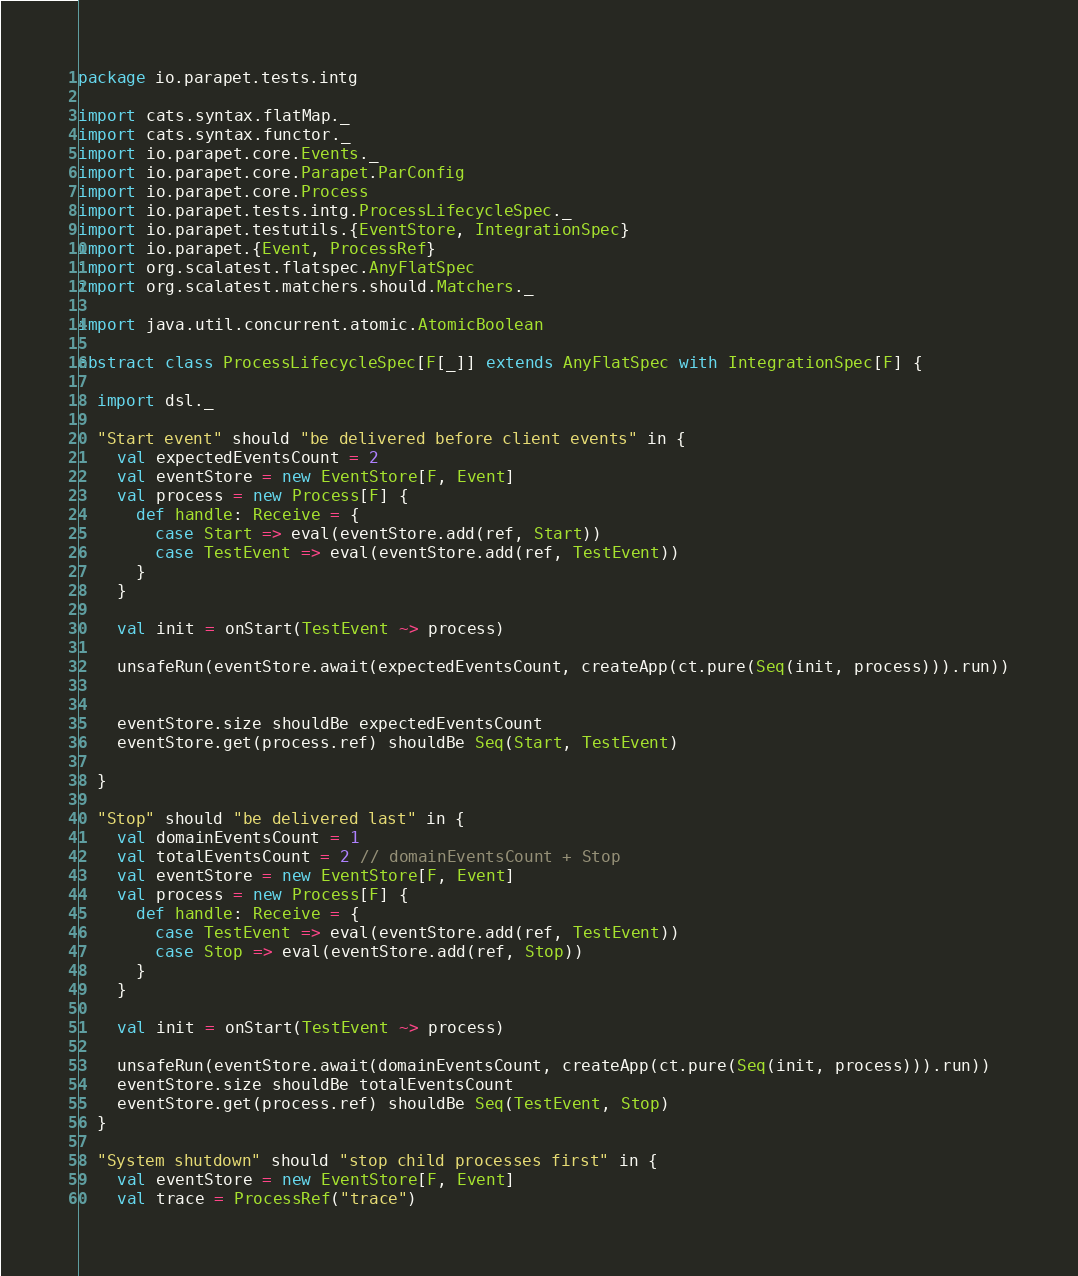<code> <loc_0><loc_0><loc_500><loc_500><_Scala_>package io.parapet.tests.intg

import cats.syntax.flatMap._
import cats.syntax.functor._
import io.parapet.core.Events._
import io.parapet.core.Parapet.ParConfig
import io.parapet.core.Process
import io.parapet.tests.intg.ProcessLifecycleSpec._
import io.parapet.testutils.{EventStore, IntegrationSpec}
import io.parapet.{Event, ProcessRef}
import org.scalatest.flatspec.AnyFlatSpec
import org.scalatest.matchers.should.Matchers._

import java.util.concurrent.atomic.AtomicBoolean

abstract class ProcessLifecycleSpec[F[_]] extends AnyFlatSpec with IntegrationSpec[F] {

  import dsl._

  "Start event" should "be delivered before client events" in {
    val expectedEventsCount = 2
    val eventStore = new EventStore[F, Event]
    val process = new Process[F] {
      def handle: Receive = {
        case Start => eval(eventStore.add(ref, Start))
        case TestEvent => eval(eventStore.add(ref, TestEvent))
      }
    }

    val init = onStart(TestEvent ~> process)

    unsafeRun(eventStore.await(expectedEventsCount, createApp(ct.pure(Seq(init, process))).run))


    eventStore.size shouldBe expectedEventsCount
    eventStore.get(process.ref) shouldBe Seq(Start, TestEvent)

  }

  "Stop" should "be delivered last" in {
    val domainEventsCount = 1
    val totalEventsCount = 2 // domainEventsCount + Stop
    val eventStore = new EventStore[F, Event]
    val process = new Process[F] {
      def handle: Receive = {
        case TestEvent => eval(eventStore.add(ref, TestEvent))
        case Stop => eval(eventStore.add(ref, Stop))
      }
    }

    val init = onStart(TestEvent ~> process)

    unsafeRun(eventStore.await(domainEventsCount, createApp(ct.pure(Seq(init, process))).run))
    eventStore.size shouldBe totalEventsCount
    eventStore.get(process.ref) shouldBe Seq(TestEvent, Stop)
  }

  "System shutdown" should "stop child processes first" in {
    val eventStore = new EventStore[F, Event]
    val trace = ProcessRef("trace")
</code> 